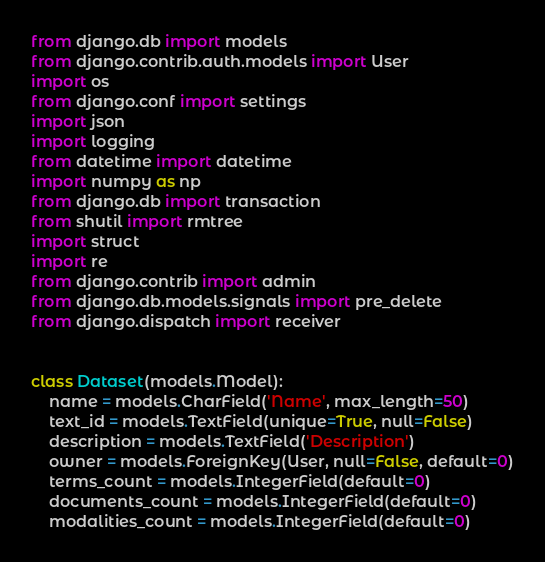<code> <loc_0><loc_0><loc_500><loc_500><_Python_>from django.db import models
from django.contrib.auth.models import User
import os
from django.conf import settings
import json
import logging
from datetime import datetime
import numpy as np
from django.db import transaction
from shutil import rmtree
import struct
import re
from django.contrib import admin
from django.db.models.signals import pre_delete
from django.dispatch import receiver


class Dataset(models.Model):
    name = models.CharField('Name', max_length=50)
    text_id = models.TextField(unique=True, null=False)
    description = models.TextField('Description')
    owner = models.ForeignKey(User, null=False, default=0)
    terms_count = models.IntegerField(default=0)
    documents_count = models.IntegerField(default=0)
    modalities_count = models.IntegerField(default=0)</code> 